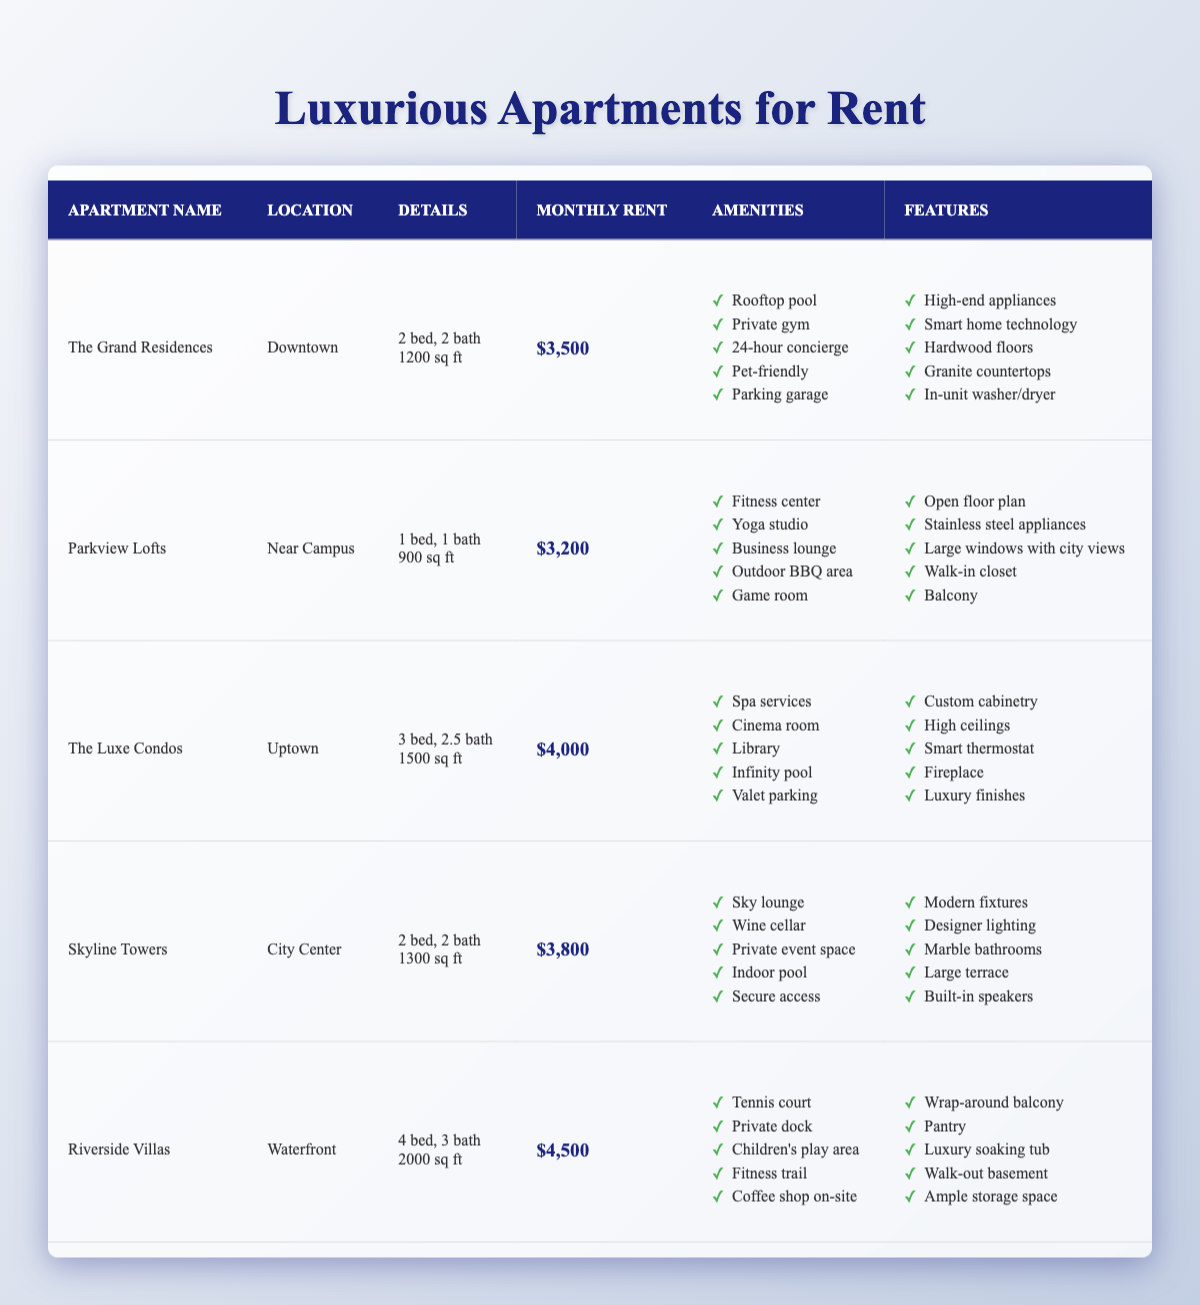What is the monthly rent for The Luxe Condos? The monthly rent for The Luxe Condos can be found in the 'Monthly Rent' column of the table, which lists it as $4,000.
Answer: $4,000 How many bedrooms are in Skyline Towers? The table shows that Skyline Towers has 2 bedrooms listed in the 'Details' column.
Answer: 2 Which apartment has the least number of bathrooms? By checking the 'Details' column, we see that Parkview Lofts has 1 bathroom, which is fewer than the others.
Answer: Parkview Lofts What is the total square footage of The Grand Residences and Parkview Lofts together? The square footage for The Grand Residences is 1200 sq ft, and for Parkview Lofts, it is 900 sq ft. Adding them together: 1200 + 900 = 2100 sq ft.
Answer: 2100 sq ft Is The Grand Residences pet-friendly? The 'Amenities' column for The Grand Residences includes 'Pet-friendly', which confirms it is indeed pet-friendly.
Answer: Yes Which apartment has the most bathrooms? Riverside Villas has the most bathrooms listed with 3 in the 'Details' column, compared to the others with fewer.
Answer: Riverside Villas How much more expensive is Riverside Villas than Parkview Lofts? Riverside Villas has a monthly rent of $4,500, while Parkview Lofts costs $3,200. The difference is $4,500 - $3,200 = $1,300.
Answer: $1,300 What is the average monthly rent of all apartments listed? The monthly rents are $3,500, $3,200, $4,000, $3,800, and $4,500. Adding these gives $3,500 + $3,200 + $4,000 + $3,800 + $4,500 = $18,000. There are 5 apartments, so the average rent is $18,000 / 5 = $3,600.
Answer: $3,600 Which apartments have a rooftop pool? Checking the 'Amenities' column, only The Grand Residences lists a rooftop pool as an amenity.
Answer: The Grand Residences How many amenities does Skyline Towers provide? The amenities listed for Skyline Towers are 'Sky lounge', 'Wine cellar', 'Private event space', 'Indoor pool', and 'Secure access', totaling 5 amenities.
Answer: 5 Is there an apartment with a private dock? Yes, Riverside Villas lists 'Private dock' in the 'Amenities' column, confirming it has this feature.
Answer: Yes 